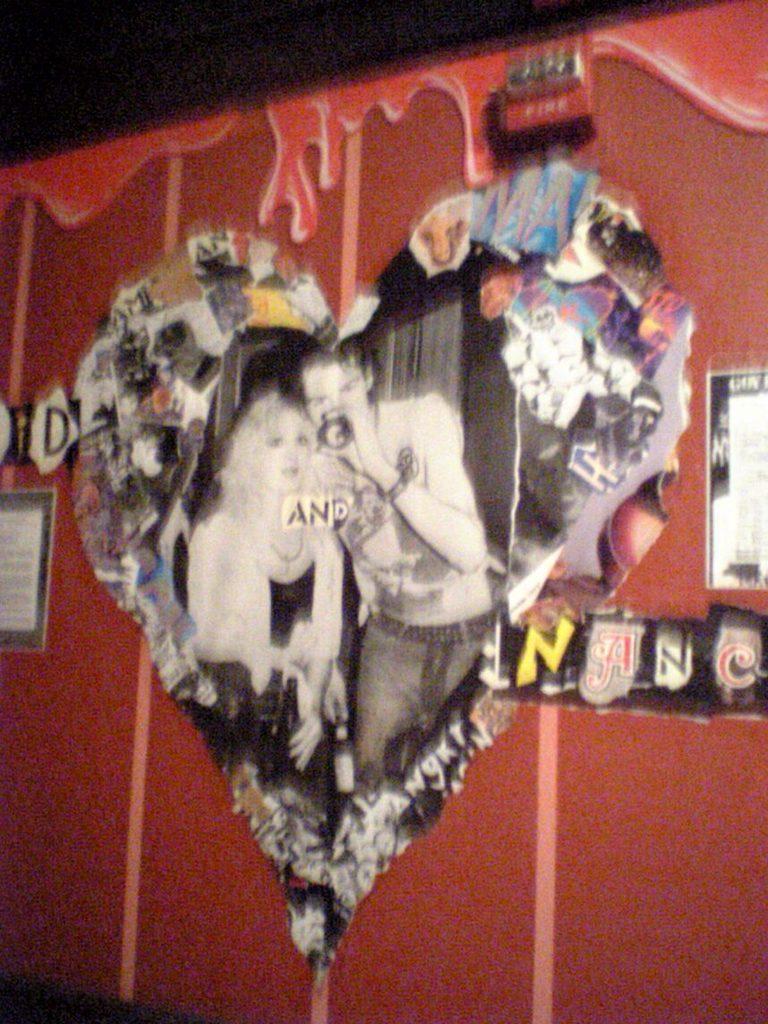How would you summarize this image in a sentence or two? In this picture we can see the posters on the wall. At the top, the image is dark. 